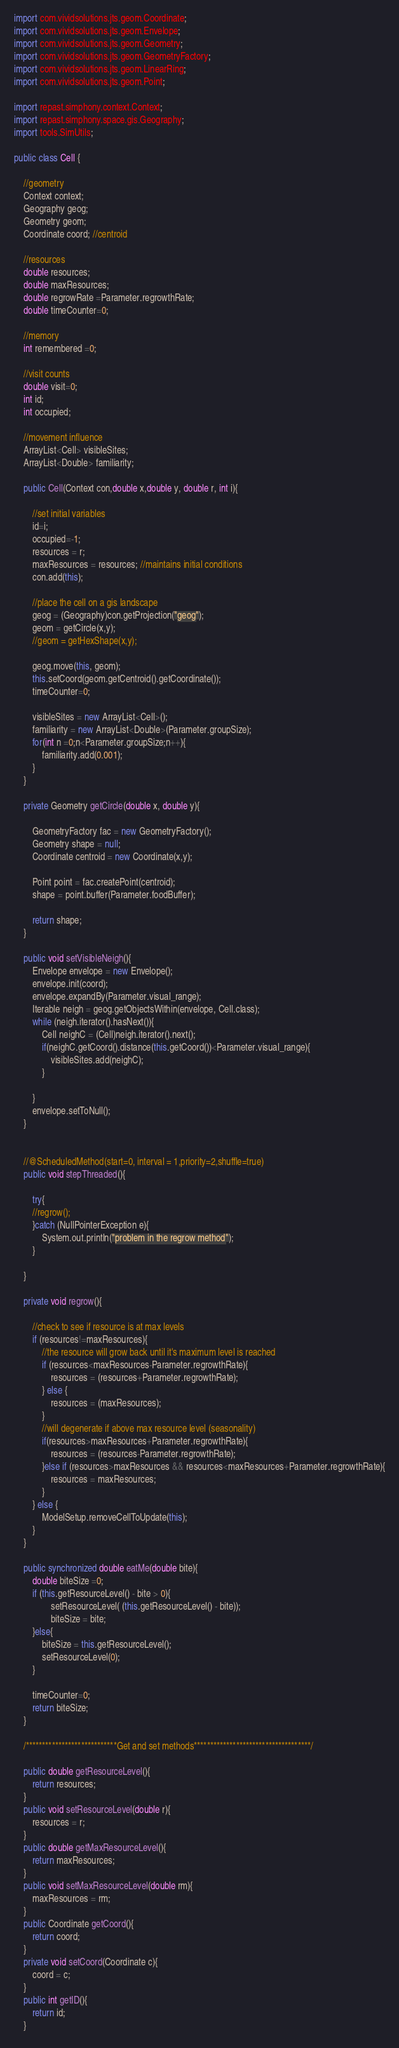Convert code to text. <code><loc_0><loc_0><loc_500><loc_500><_Java_>import com.vividsolutions.jts.geom.Coordinate;
import com.vividsolutions.jts.geom.Envelope;
import com.vividsolutions.jts.geom.Geometry;
import com.vividsolutions.jts.geom.GeometryFactory;
import com.vividsolutions.jts.geom.LinearRing;
import com.vividsolutions.jts.geom.Point;

import repast.simphony.context.Context;
import repast.simphony.space.gis.Geography;
import tools.SimUtils;

public class Cell {
	
	//geometry
	Context context;
	Geography geog;
	Geometry geom;
	Coordinate coord; //centroid
	
	//resources
	double resources;
	double maxResources;
	double regrowRate =Parameter.regrowthRate;
	double timeCounter=0;
	
	//memory
	int remembered =0;
	
	//visit counts
	double visit=0;
	int id;
	int occupied;
	
	//movement influence
	ArrayList<Cell> visibleSites;
	ArrayList<Double> familiarity;
	
	public Cell(Context con,double x,double y, double r, int i){
		
		//set initial variables
		id=i;
		occupied=-1;
		resources = r;
		maxResources = resources; //maintains initial conditions
		con.add(this);
		
		//place the cell on a gis landscape
		geog = (Geography)con.getProjection("geog");
		geom = getCircle(x,y);
		//geom = getHexShape(x,y);
		
		geog.move(this, geom);
		this.setCoord(geom.getCentroid().getCoordinate());
		timeCounter=0;
		
		visibleSites = new ArrayList<Cell>();
		familiarity = new ArrayList<Double>(Parameter.groupSize);
		for(int n =0;n<Parameter.groupSize;n++){
			familiarity.add(0.001);
		}
	}
	
	private Geometry getCircle(double x, double y){
		
		GeometryFactory fac = new GeometryFactory();
		Geometry shape = null;
		Coordinate centroid = new Coordinate(x,y);
		
		Point point = fac.createPoint(centroid);
		shape = point.buffer(Parameter.foodBuffer);
		
		return shape;
	}
	
	public void setVisibleNeigh(){
		Envelope envelope = new Envelope();
		envelope.init(coord);
		envelope.expandBy(Parameter.visual_range);
		Iterable neigh = geog.getObjectsWithin(envelope, Cell.class);
		while (neigh.iterator().hasNext()){
			Cell neighC = (Cell)neigh.iterator().next();
			if(neighC.getCoord().distance(this.getCoord())<Parameter.visual_range){
				visibleSites.add(neighC);	
			}
			
		}
		envelope.setToNull();
	}
	
	
	//@ScheduledMethod(start=0, interval = 1,priority=2,shuffle=true)
	public void stepThreaded(){
		
		try{
		//regrow();
		}catch (NullPointerException e){
			System.out.println("problem in the regrow method");
		}
		
	}
	
	private void regrow(){
		
		//check to see if resource is at max levels
		if (resources!=maxResources){
			//the resource will grow back until it's maximum level is reached
			if (resources<maxResources-Parameter.regrowthRate){
				resources = (resources+Parameter.regrowthRate);
			} else {
				resources = (maxResources);
			}
			//will degenerate if above max resource level (seasonality)
			if(resources>maxResources+Parameter.regrowthRate){
				resources = (resources-Parameter.regrowthRate);
			}else if (resources>maxResources && resources<maxResources+Parameter.regrowthRate){
				resources = maxResources;
			}
		} else {
			ModelSetup.removeCellToUpdate(this);
		}
	}
	
	public synchronized double eatMe(double bite){
		double biteSize =0;
		if (this.getResourceLevel() - bite > 0){
				setResourceLevel( (this.getResourceLevel() - bite));
				biteSize = bite;
		}else{
			biteSize = this.getResourceLevel();
			setResourceLevel(0);
		}
		
		timeCounter=0;
		return biteSize;
	}
	
	/****************************Get and set methods************************************/
	
	public double getResourceLevel(){
		return resources;
	}
	public void setResourceLevel(double r){
		resources = r;
	}
	public double getMaxResourceLevel(){
		return maxResources;
	}
	public void setMaxResourceLevel(double rm){
		maxResources = rm;
	}
	public Coordinate getCoord(){
		return coord;
	}
	private void setCoord(Coordinate c){
		coord = c;
	}
	public int getID(){
		return id;
	}
</code> 